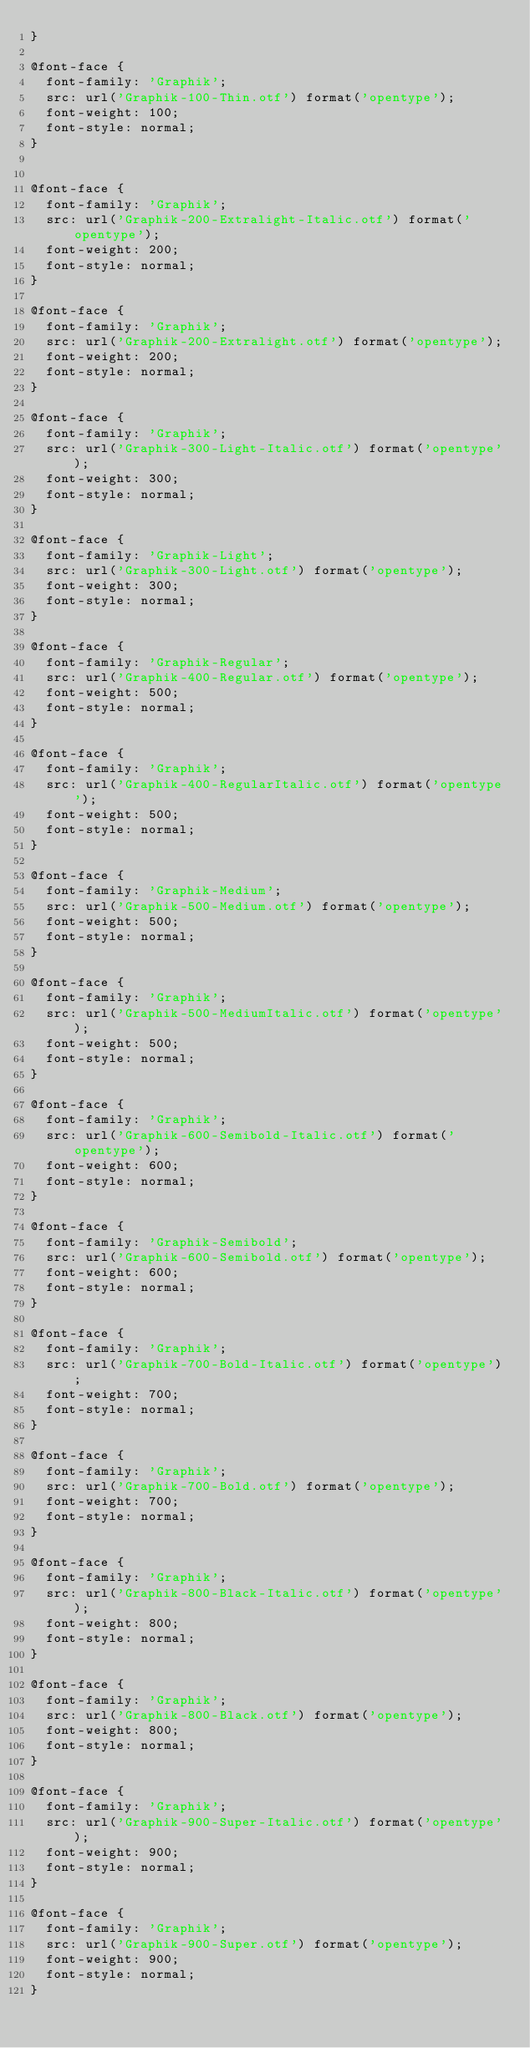Convert code to text. <code><loc_0><loc_0><loc_500><loc_500><_CSS_>}

@font-face {
  font-family: 'Graphik';
  src: url('Graphik-100-Thin.otf') format('opentype');
  font-weight: 100;
  font-style: normal;
}


@font-face {
  font-family: 'Graphik';
  src: url('Graphik-200-Extralight-Italic.otf') format('opentype');
  font-weight: 200;
  font-style: normal;
}

@font-face {
  font-family: 'Graphik';
  src: url('Graphik-200-Extralight.otf') format('opentype');
  font-weight: 200;
  font-style: normal;
}

@font-face {
  font-family: 'Graphik';
  src: url('Graphik-300-Light-Italic.otf') format('opentype');
  font-weight: 300;
  font-style: normal;
}

@font-face {
  font-family: 'Graphik-Light';
  src: url('Graphik-300-Light.otf') format('opentype');
  font-weight: 300;
  font-style: normal;
}

@font-face {
  font-family: 'Graphik-Regular';
  src: url('Graphik-400-Regular.otf') format('opentype');
  font-weight: 500;
  font-style: normal;
}

@font-face {
  font-family: 'Graphik';
  src: url('Graphik-400-RegularItalic.otf') format('opentype');
  font-weight: 500;
  font-style: normal;
}

@font-face {
  font-family: 'Graphik-Medium';
  src: url('Graphik-500-Medium.otf') format('opentype');
  font-weight: 500;
  font-style: normal;
}

@font-face {
  font-family: 'Graphik';
  src: url('Graphik-500-MediumItalic.otf') format('opentype');
  font-weight: 500;
  font-style: normal;
}

@font-face {
  font-family: 'Graphik';
  src: url('Graphik-600-Semibold-Italic.otf') format('opentype');
  font-weight: 600;
  font-style: normal;
}

@font-face {
  font-family: 'Graphik-Semibold';
  src: url('Graphik-600-Semibold.otf') format('opentype');
  font-weight: 600;
  font-style: normal;
}

@font-face {
  font-family: 'Graphik';
  src: url('Graphik-700-Bold-Italic.otf') format('opentype');
  font-weight: 700;
  font-style: normal;
}

@font-face {
  font-family: 'Graphik';
  src: url('Graphik-700-Bold.otf') format('opentype');
  font-weight: 700;
  font-style: normal;
}

@font-face {
  font-family: 'Graphik';
  src: url('Graphik-800-Black-Italic.otf') format('opentype');
  font-weight: 800;
  font-style: normal;
}

@font-face {
  font-family: 'Graphik';
  src: url('Graphik-800-Black.otf') format('opentype');
  font-weight: 800;
  font-style: normal;
}

@font-face {
  font-family: 'Graphik';
  src: url('Graphik-900-Super-Italic.otf') format('opentype');
  font-weight: 900;
  font-style: normal;
}

@font-face {
  font-family: 'Graphik';
  src: url('Graphik-900-Super.otf') format('opentype');
  font-weight: 900;
  font-style: normal;
}
</code> 